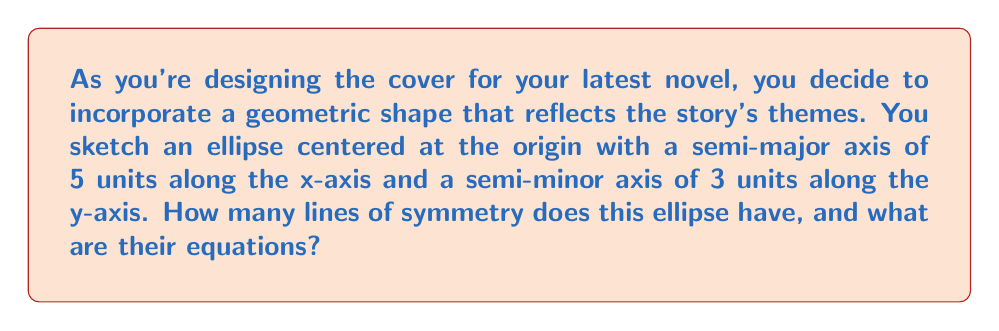Solve this math problem. Let's approach this step-by-step:

1) The general equation of an ellipse centered at the origin is:

   $$\frac{x^2}{a^2} + \frac{y^2}{b^2} = 1$$

   where $a$ is the length of the semi-major axis and $b$ is the length of the semi-minor axis.

2) In this case, $a = 5$ and $b = 3$, so the equation of our ellipse is:

   $$\frac{x^2}{25} + \frac{y^2}{9} = 1$$

3) To determine the lines of symmetry, we need to consider the following:
   - An ellipse always has two lines of symmetry: one along its major axis and one along its minor axis.
   - These lines of symmetry intersect at the center of the ellipse.

4) Since the ellipse is centered at the origin (0, 0), and the semi-major axis is along the x-axis:
   - The x-axis (y = 0) is one line of symmetry
   - The y-axis (x = 0) is the other line of symmetry

5) We can verify this visually:

   [asy]
   import geometry;

   size(200);
   
   ellipse e = ellipse((0,0), 5, 3);
   draw(e);
   
   draw((-6,0)--(6,0), arrow=Arrow(TeXHead));
   draw((0,-4)--(0,4), arrow=Arrow(TeXHead));
   
   label("x", (6,0), E);
   label("y", (0,4), N);
   
   dot((0,0));
   
   [/asy]

6) Therefore, the lines of symmetry are:
   - y = 0 (the x-axis)
   - x = 0 (the y-axis)
Answer: The ellipse has 2 lines of symmetry: $y = 0$ and $x = 0$. 